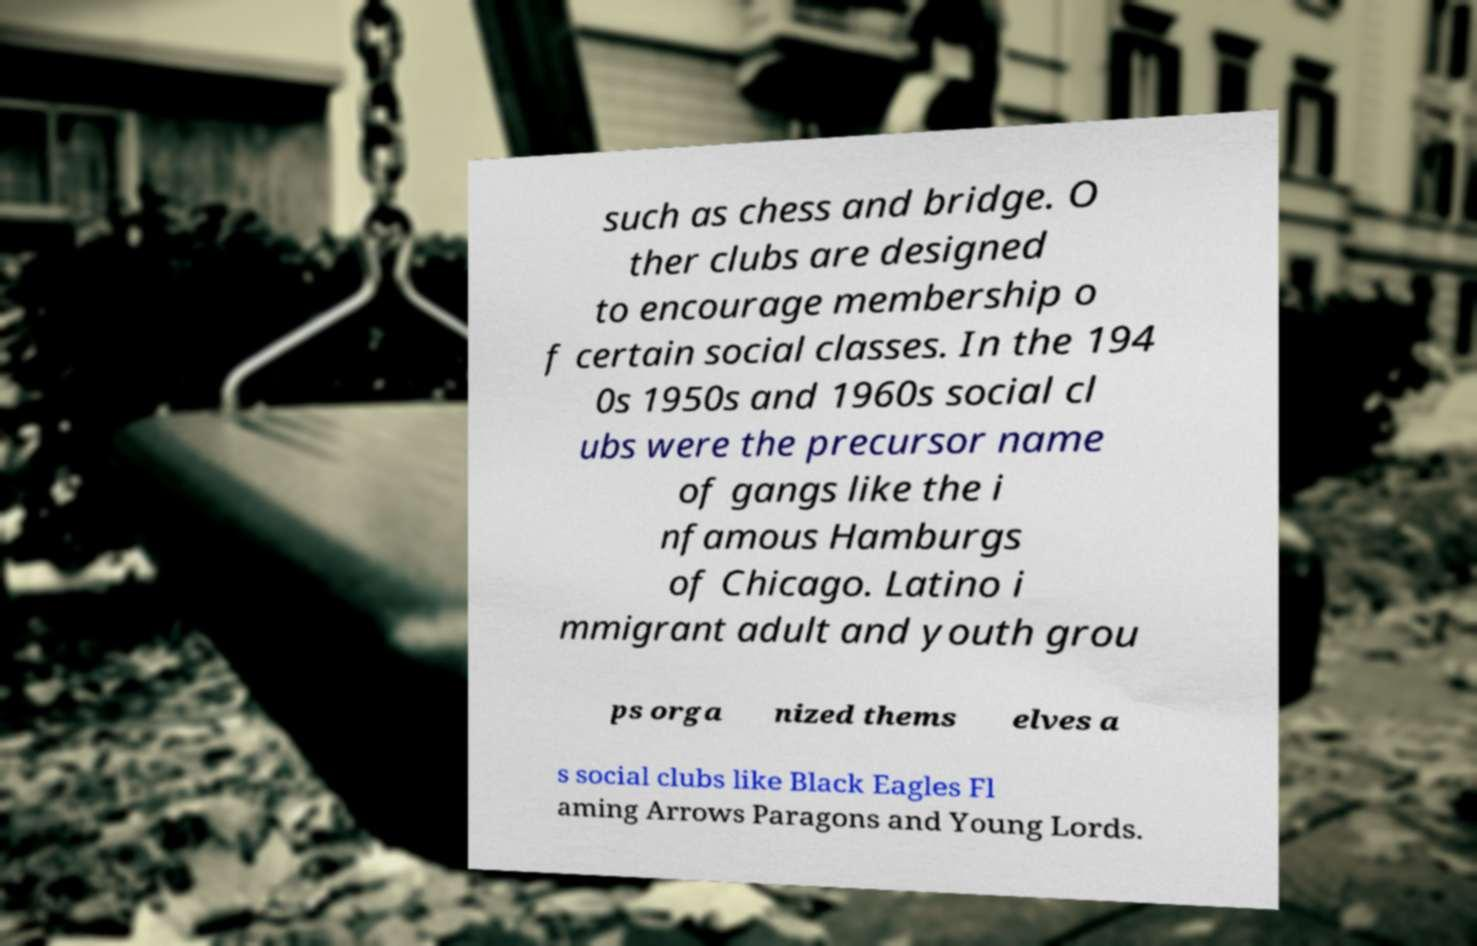Can you read and provide the text displayed in the image?This photo seems to have some interesting text. Can you extract and type it out for me? such as chess and bridge. O ther clubs are designed to encourage membership o f certain social classes. In the 194 0s 1950s and 1960s social cl ubs were the precursor name of gangs like the i nfamous Hamburgs of Chicago. Latino i mmigrant adult and youth grou ps orga nized thems elves a s social clubs like Black Eagles Fl aming Arrows Paragons and Young Lords. 